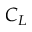Convert formula to latex. <formula><loc_0><loc_0><loc_500><loc_500>C _ { L }</formula> 